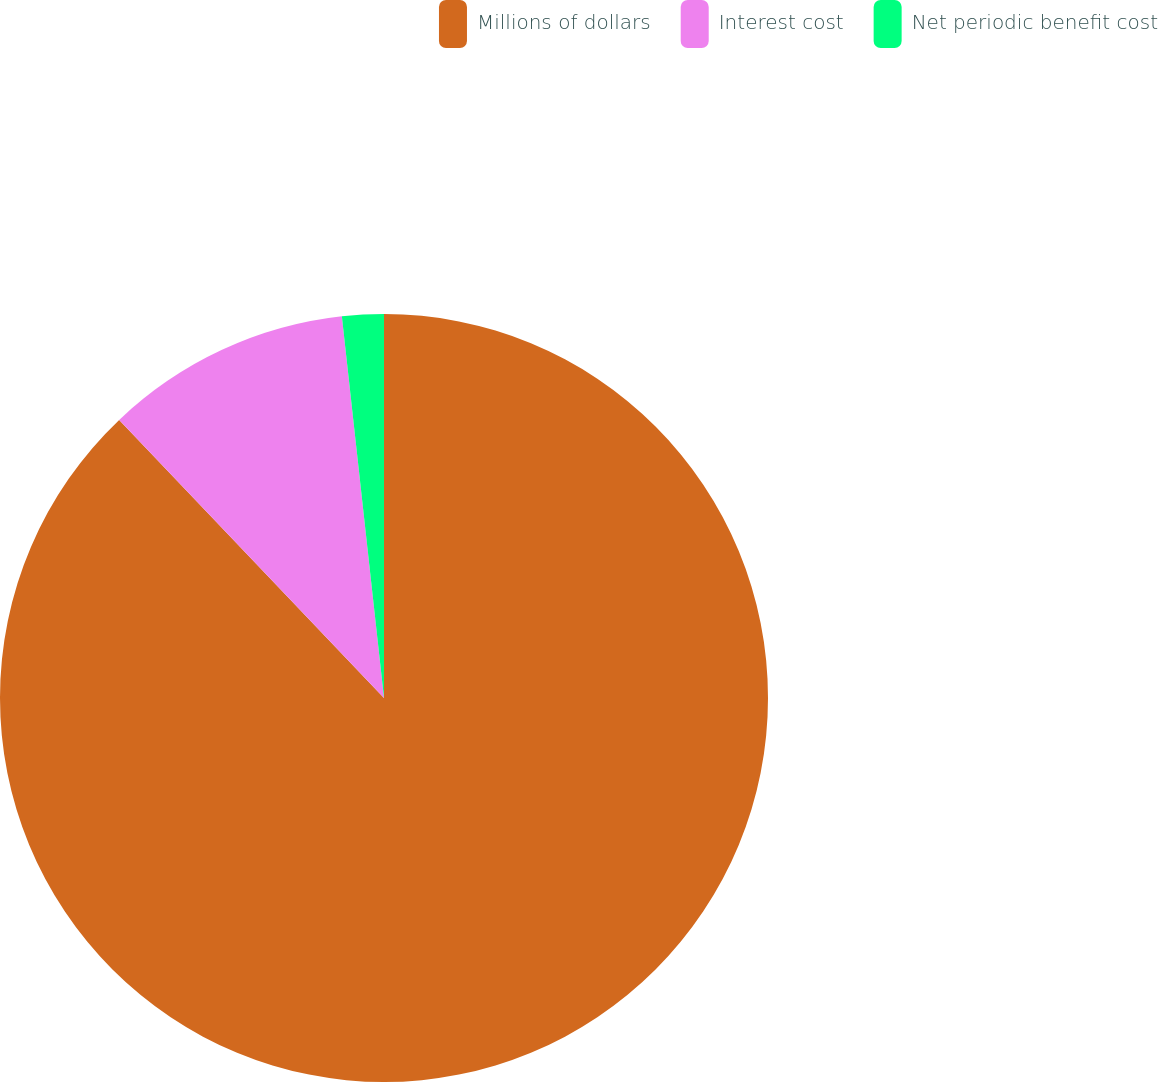Convert chart. <chart><loc_0><loc_0><loc_500><loc_500><pie_chart><fcel>Millions of dollars<fcel>Interest cost<fcel>Net periodic benefit cost<nl><fcel>87.88%<fcel>10.36%<fcel>1.75%<nl></chart> 